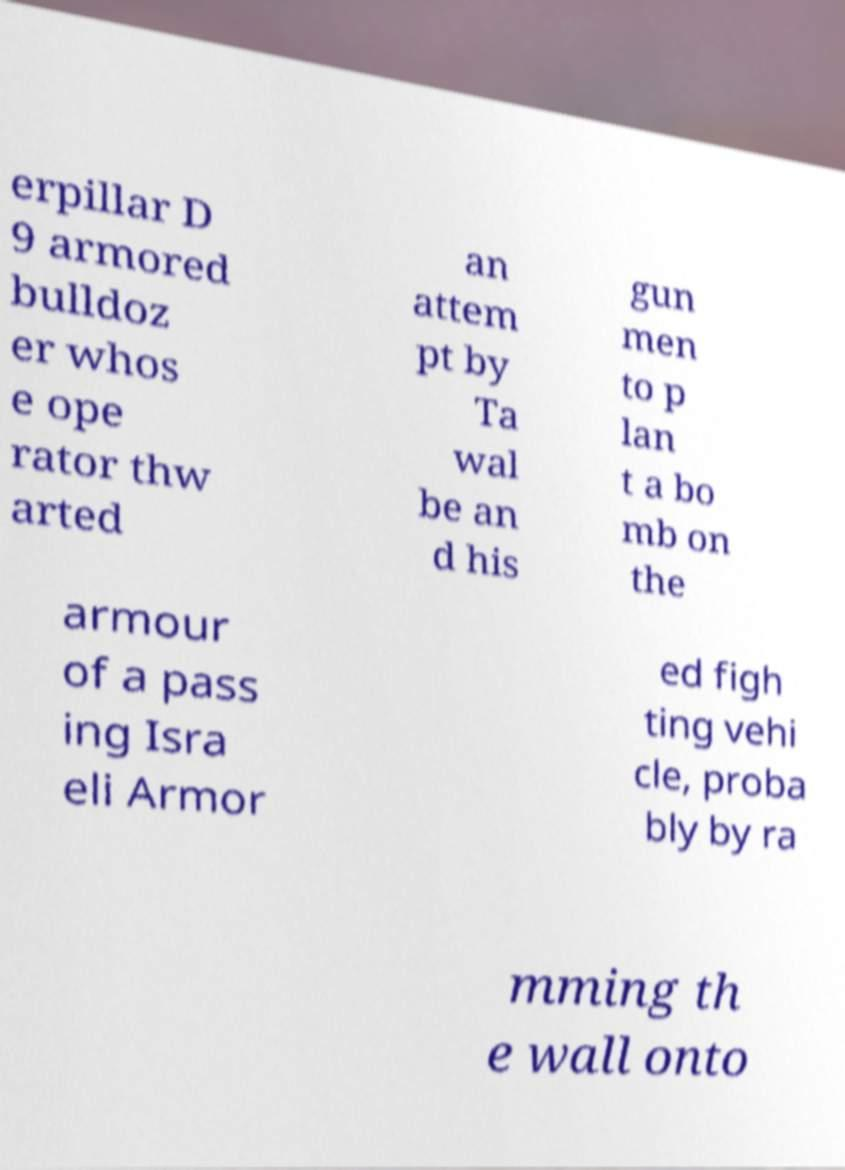Can you read and provide the text displayed in the image?This photo seems to have some interesting text. Can you extract and type it out for me? erpillar D 9 armored bulldoz er whos e ope rator thw arted an attem pt by Ta wal be an d his gun men to p lan t a bo mb on the armour of a pass ing Isra eli Armor ed figh ting vehi cle, proba bly by ra mming th e wall onto 